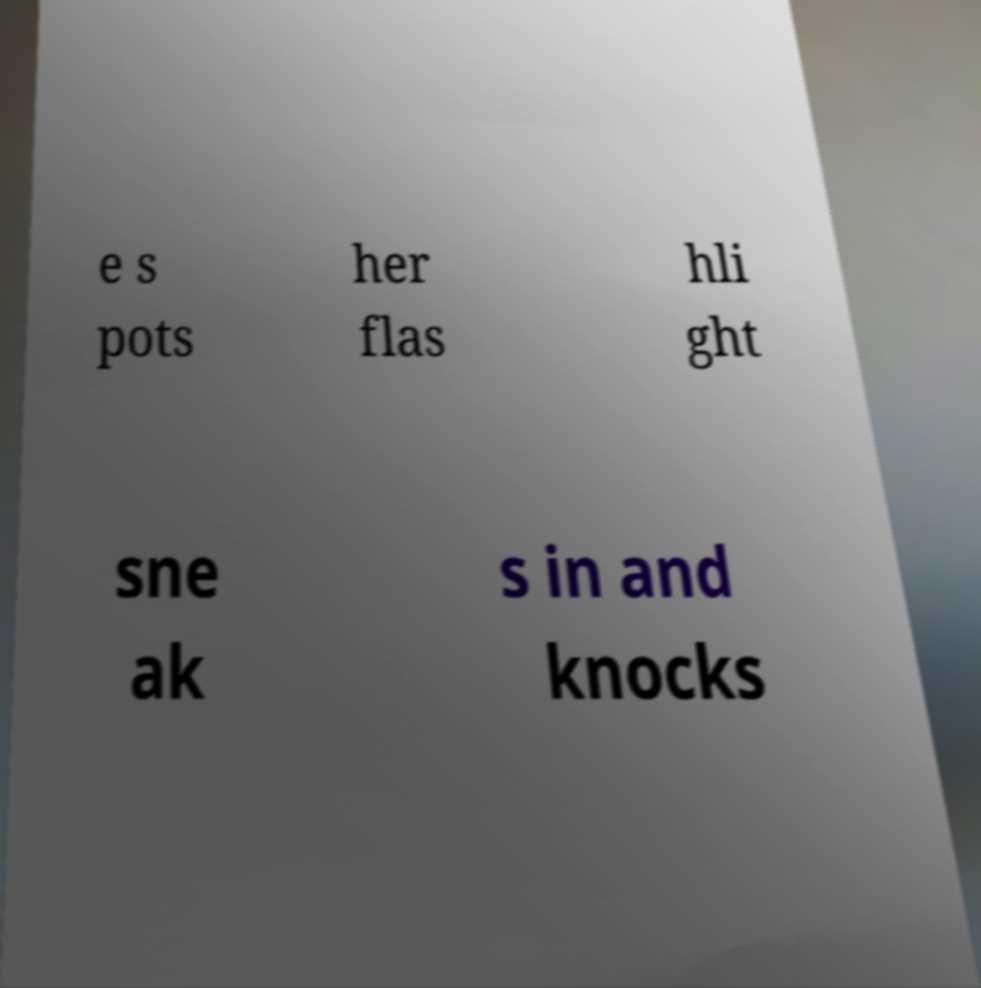Please read and relay the text visible in this image. What does it say? e s pots her flas hli ght sne ak s in and knocks 